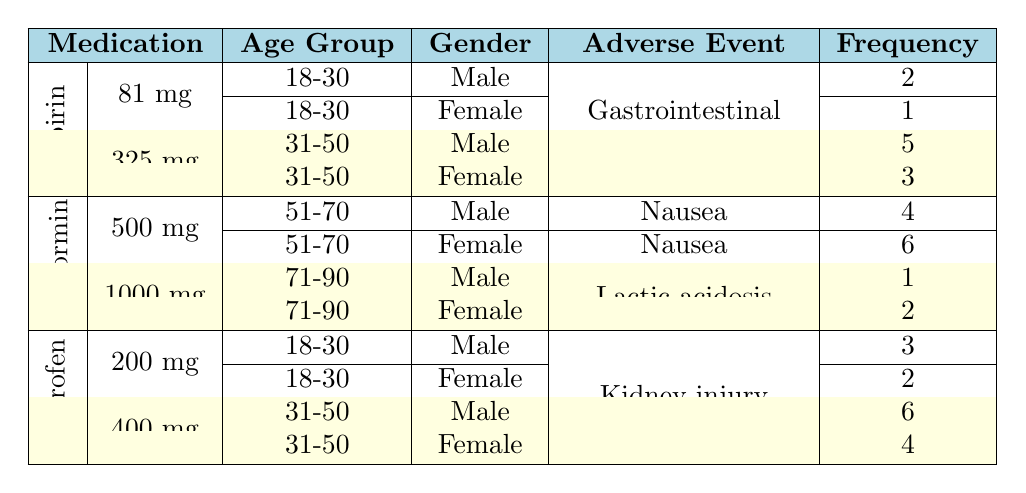What is the frequency of gastrointestinal bleeding for females aged 18-30 taking Aspirin? From the table, under the medication Aspirin and the dosage of 81 mg, we can see that the frequency of gastrointestinal bleeding for females aged 18-30 is listed as 1.
Answer: 1 How many total adverse events are reported for Ibuprofen at a dosage of 400 mg? For the medication Ibuprofen at 400 mg, there are two entries: one for males with a frequency of 6, and one for females with a frequency of 4. Adding these gives us 6 + 4 = 10 total adverse events for this dosage.
Answer: 10 Did any female patient report lactic acidosis while taking Metformin at 1000 mg? Checking the table, there is an entry for females aged 71-90 taking Metformin at 1000 mg who reported lactic acidosis, with a frequency of 2. This confirms that at least one female patient reported this adverse event.
Answer: Yes What is the difference in frequency of kidney injury between males and females aged 31-50 taking Ibuprofen at 400 mg? For Ibuprofen 400 mg, the frequency for males is 6 and for females is 4. The difference is calculated as 6 - 4 = 2, which indicates that males reported 2 more cases of kidney injury compared to females in this age group.
Answer: 2 Which medication has the highest frequency of adverse events related to nausea among both genders aged 51-70? By reviewing the table, Metformin at 500 mg shows frequencies of 4 for males and 6 for females, totaling 10. Since it is the only medication in this category in the table, it has the highest frequency for nausea among both genders aged 51-70.
Answer: Metformin For males aged 18-30, which medication has a higher incidence of adverse events, Aspirin or Ibuprofen? Looking at the table, Aspirin 81 mg has a frequency of 2 for males aged 18-30, while Ibuprofen 200 mg has a frequency of 3 for the same demographic. Therefore, Ibuprofen has a higher incidence of adverse events than Aspirin in this group.
Answer: Ibuprofen What is the cumulative frequency of gastrointestinal bleeding across all reported dosages of Aspirin? Aspirin has a frequency of 2 for males aged 18-30 and 1 for females aged 18-30 at 81 mg, and for 325 mg, it has 5 for males and 3 for females aged 31-50. Summing these frequencies (2 + 1 + 5 + 3) results in a cumulative frequency of 11 for gastrointestinal bleeding associated with Aspirin.
Answer: 11 Is there any adverse event reported for males aged 71-90 taking Metformin? The table indicates that there is one entry for males aged 71-90 taking Metformin, but it shows a frequency of lactic acidosis, which is a reported adverse event. Thus, it confirms that there was an adverse event reported for this demographic.
Answer: Yes 